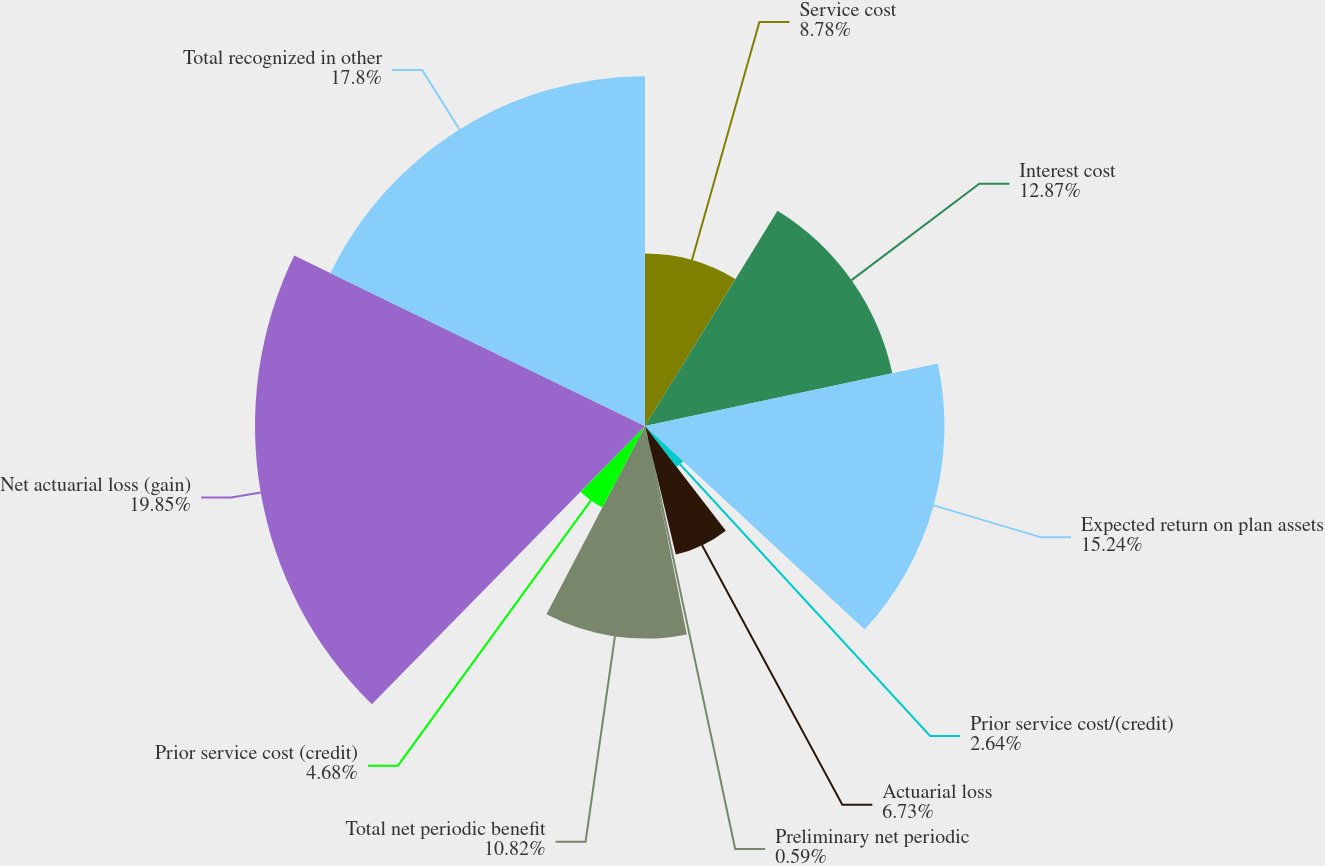Convert chart. <chart><loc_0><loc_0><loc_500><loc_500><pie_chart><fcel>Service cost<fcel>Interest cost<fcel>Expected return on plan assets<fcel>Prior service cost/(credit)<fcel>Actuarial loss<fcel>Preliminary net periodic<fcel>Total net periodic benefit<fcel>Prior service cost (credit)<fcel>Net actuarial loss (gain)<fcel>Total recognized in other<nl><fcel>8.78%<fcel>12.87%<fcel>15.24%<fcel>2.64%<fcel>6.73%<fcel>0.59%<fcel>10.82%<fcel>4.68%<fcel>19.85%<fcel>17.8%<nl></chart> 